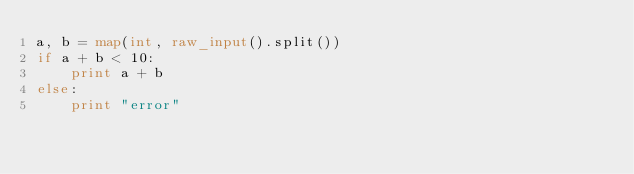Convert code to text. <code><loc_0><loc_0><loc_500><loc_500><_Python_>a, b = map(int, raw_input().split())
if a + b < 10:
    print a + b
else:
    print "error"
</code> 